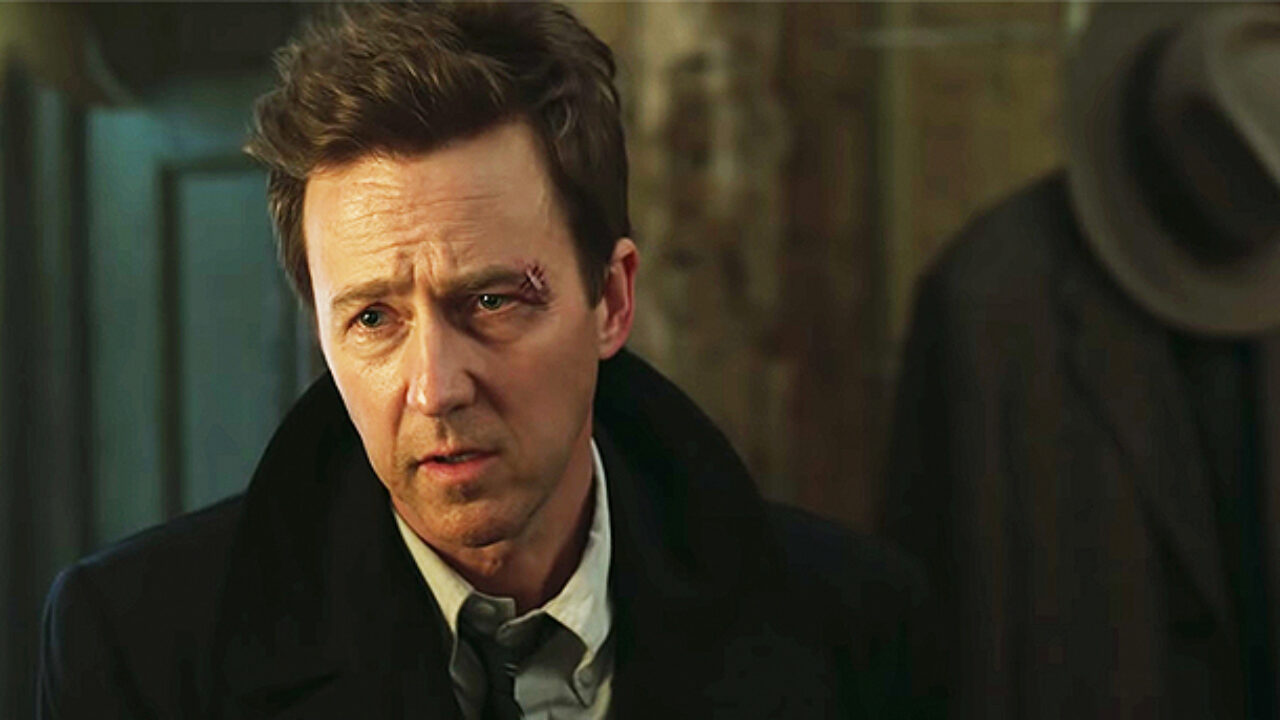What might be the significance of the coat rack in the background? The coat rack in the background is placed in a somewhat shadowed area, which might indicate it is not the central point of the scene but still adds to the setting, suggesting a public space like an office or hotel. It could symbolize the character's readiness to leave or enter into a new situation, emphasizing themes of transition or change. 